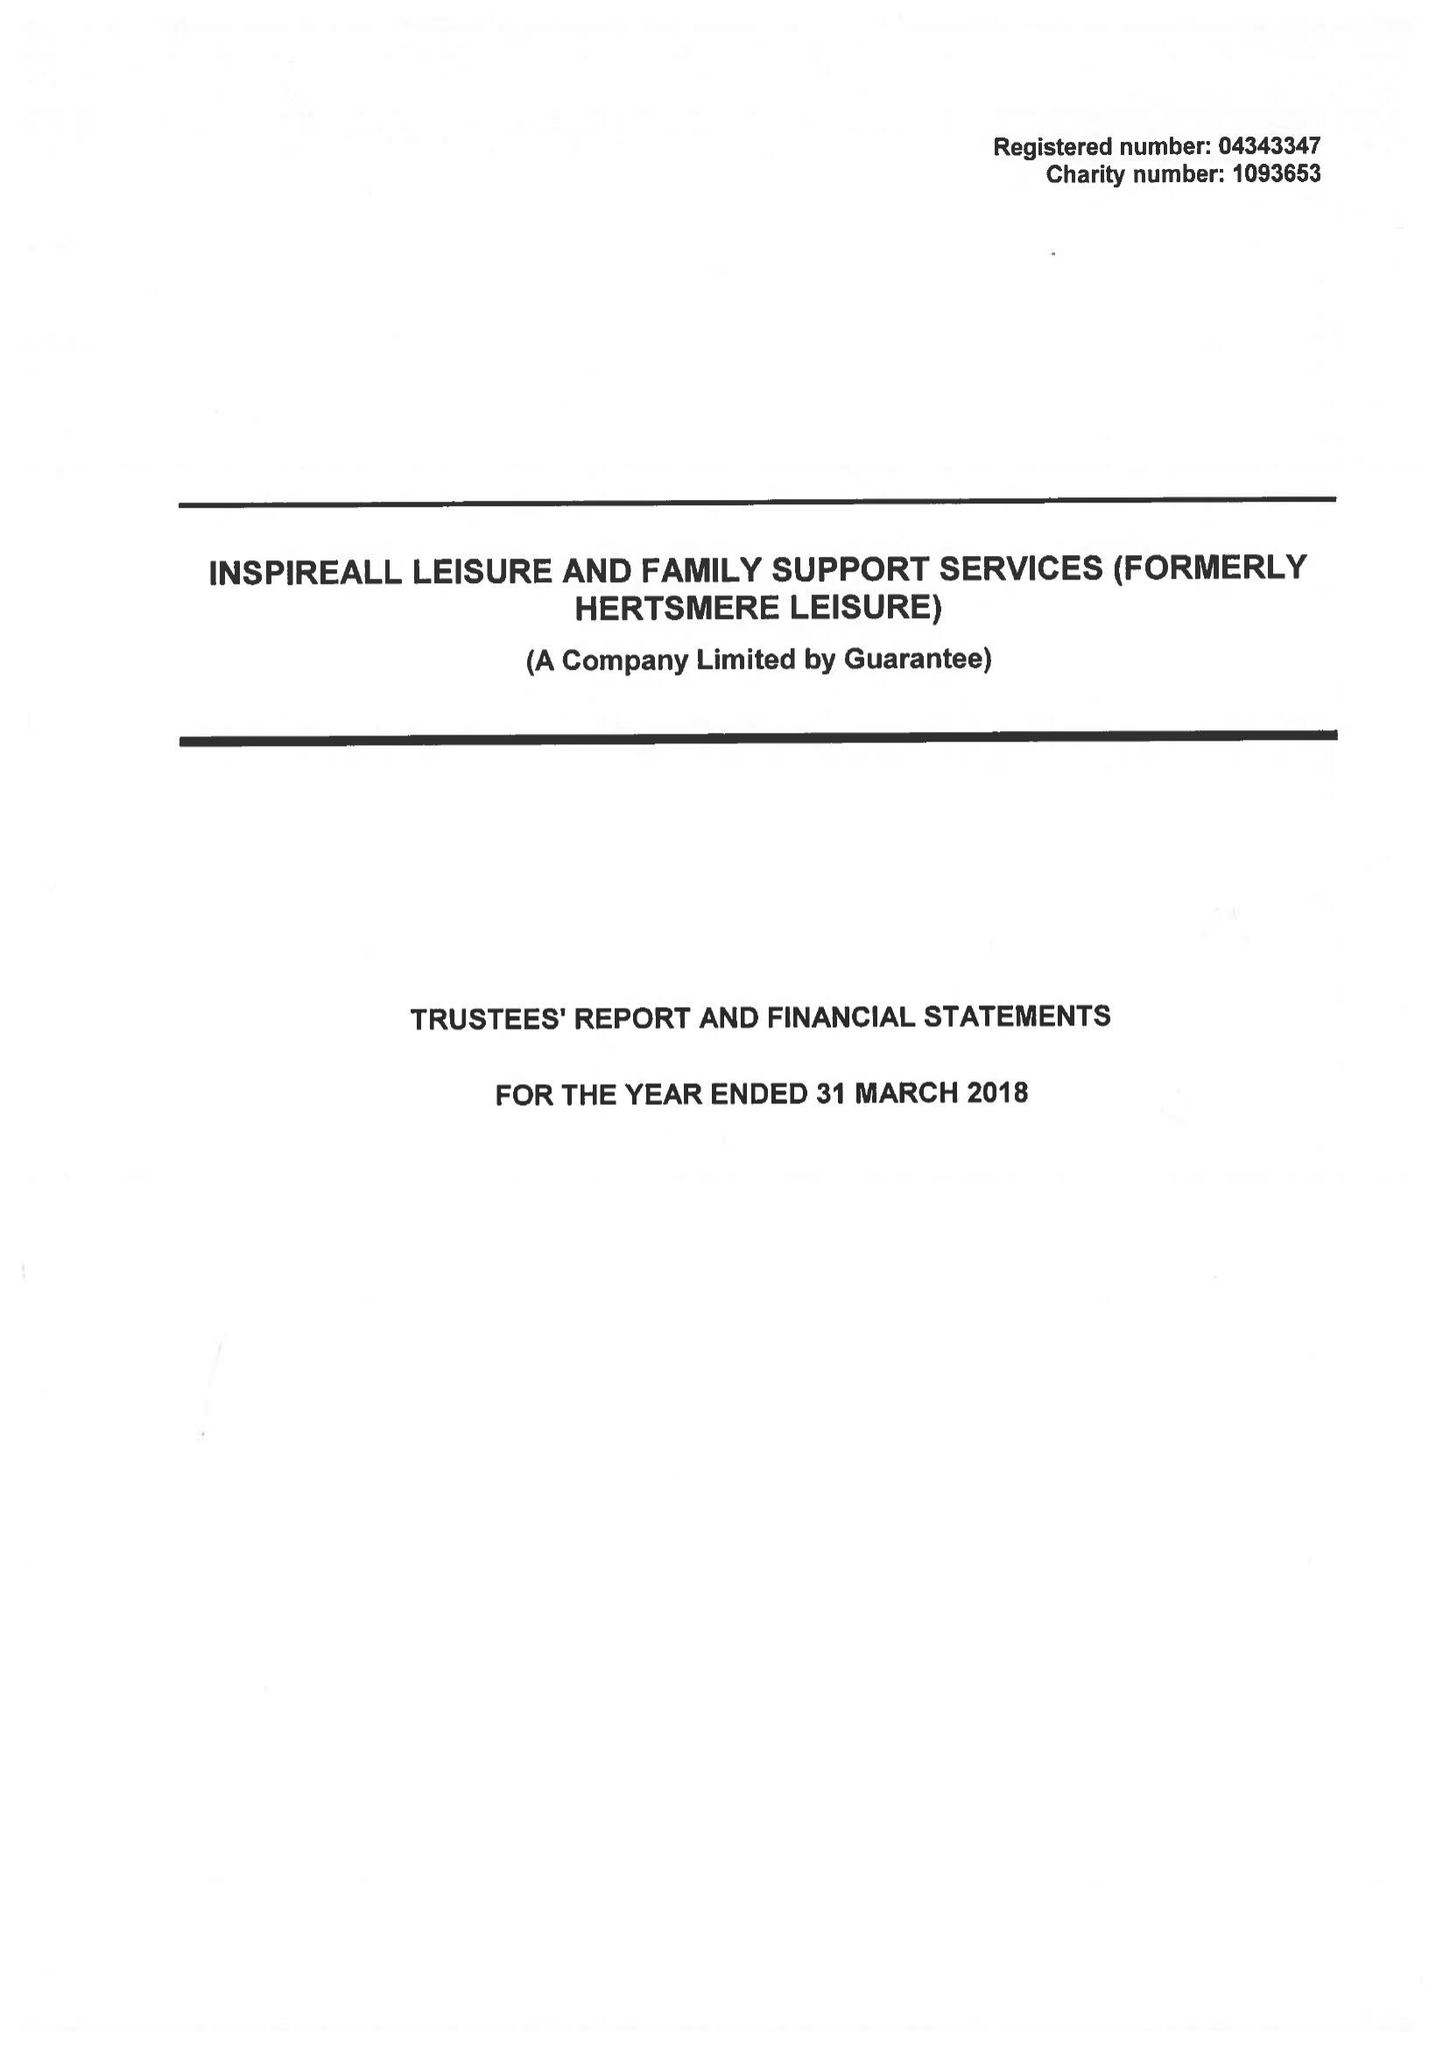What is the value for the report_date?
Answer the question using a single word or phrase. 2018-03-31 